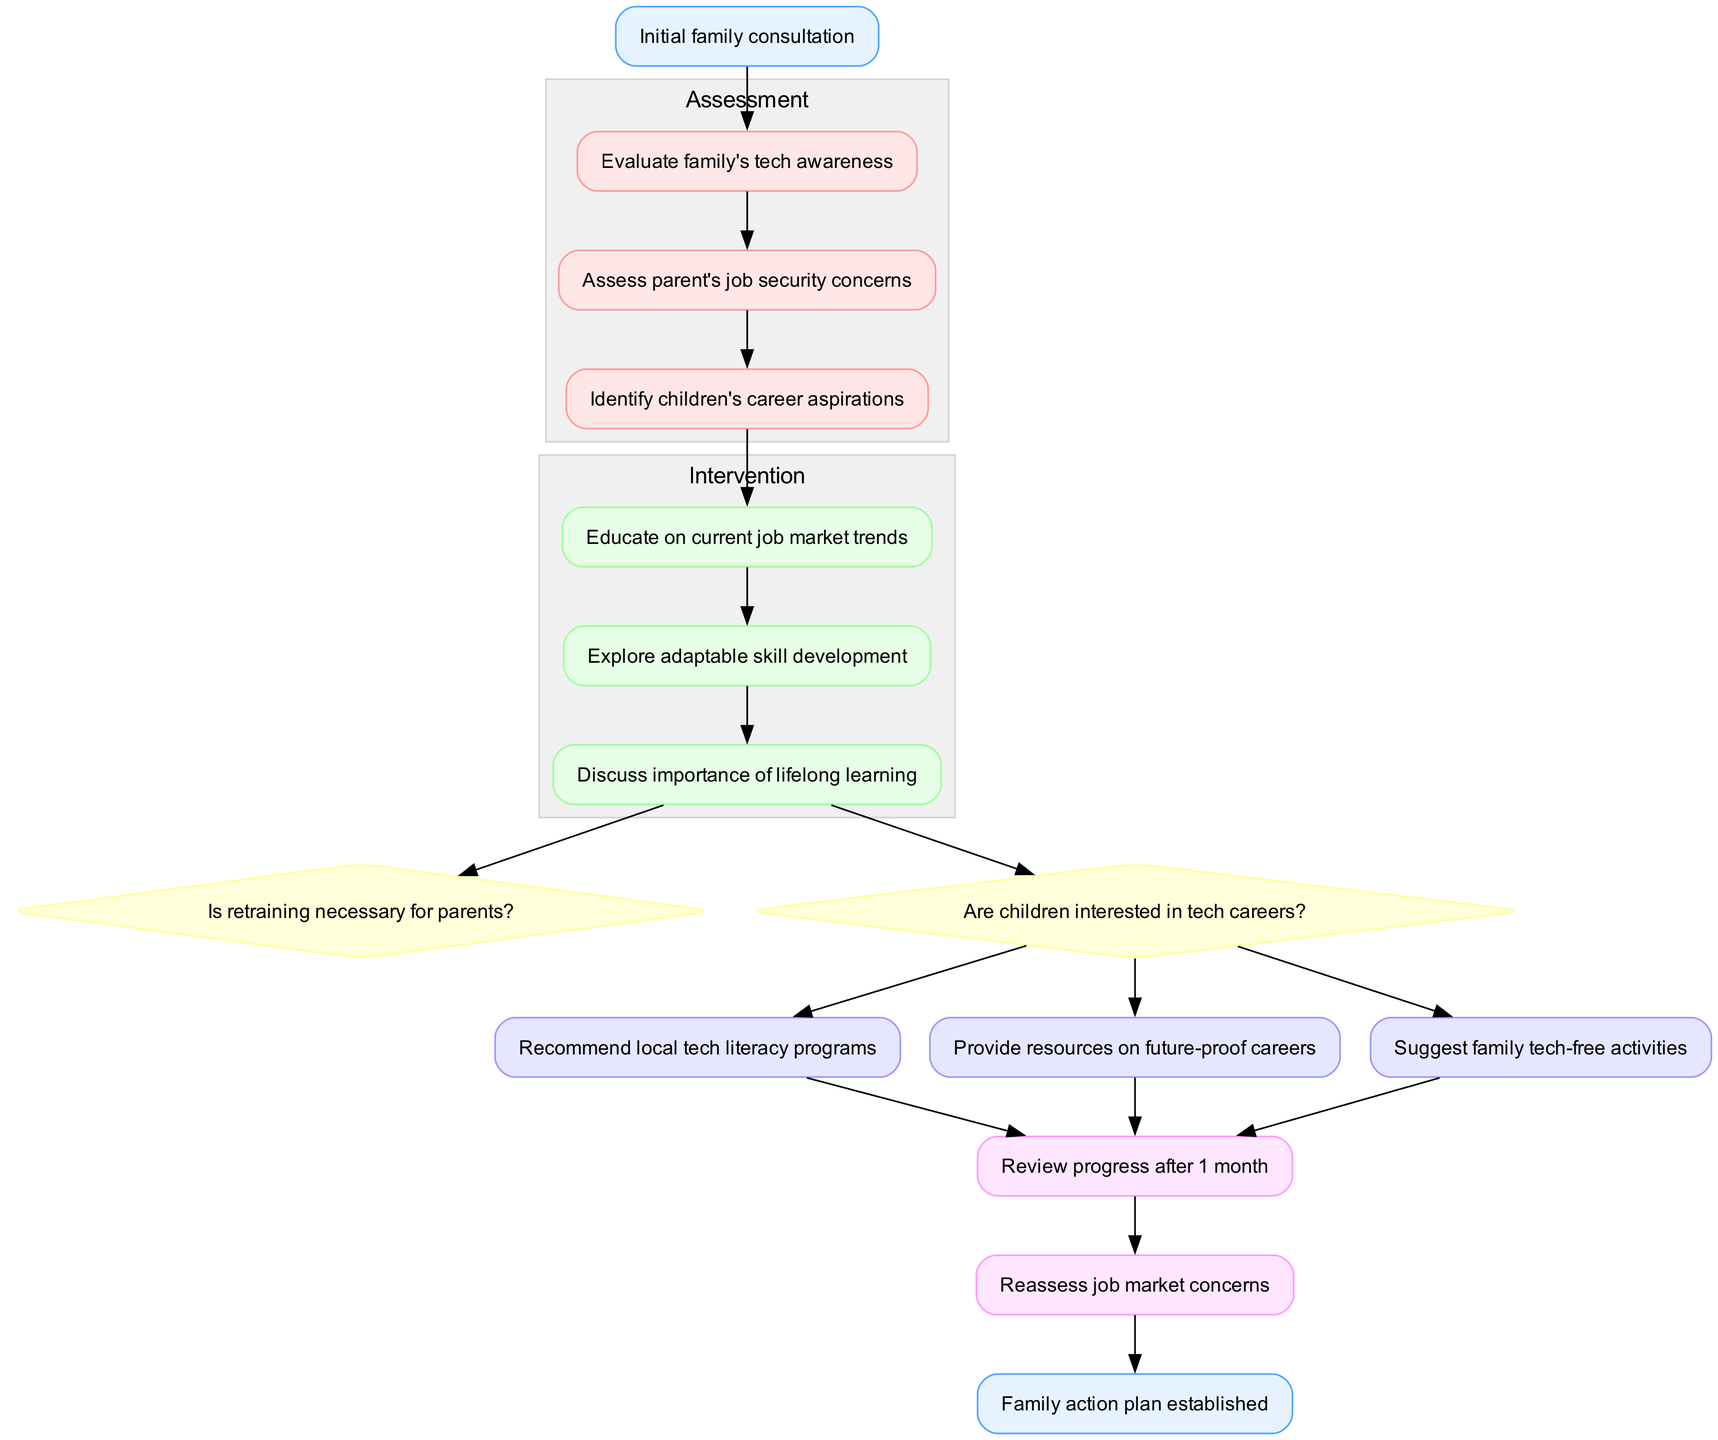What is the starting point of the pathway? The starting point is labeled as "Initial family consultation," which is the first node in the diagram.
Answer: Initial family consultation How many assessment nodes are there? The diagram lists three assessment nodes. By counting them, we find "Evaluate family's tech awareness," "Assess parent's job security concerns," and "Identify children's career aspirations."
Answer: 3 What is the first intervention node? The first intervention node is "Educate on current job market trends," which follows the last assessment node in the flow of the diagram.
Answer: Educate on current job market trends What are the decision points in the intervention phase? The decision points listed in the diagram are "Is retraining necessary for parents?" and "Are children interested in tech careers?"
Answer: Is retraining necessary for parents? and Are children interested in tech careers? What follows the last action node in the pathway? The last action node leads into the follow-up phase, which begins with "Review progress after 1 month" as the first follow-up node in the sequence.
Answer: Review progress after 1 month How many action nodes are there, and what is the last one? There are three action nodes, and the last one is "Suggest family tech-free activities," which is the final node in the action section before moving to follow-up.
Answer: 3 and Suggest family tech-free activities What is the endpoint of the clinical pathway? The endpoint is labeled as "Family action plan established," indicating the conclusion of the counseling session process in the diagram.
Answer: Family action plan established Do family tech-free activities directly influence job market concerns? The diagram does not illustrate a direct influence from "Suggest family tech-free activities" to any job market concerns, indicating that they serve as a separate recommendation rather than a direct intervention related to job security.
Answer: No 